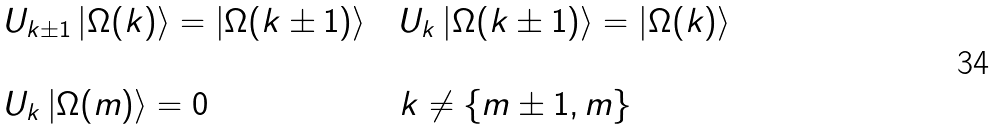Convert formula to latex. <formula><loc_0><loc_0><loc_500><loc_500>\begin{array} { l l l } U _ { k \pm 1 } \left | \Omega ( k ) \right \rangle = \left | \Omega ( k \pm 1 ) \right \rangle & & U _ { k } \left | \Omega ( k \pm 1 ) \right \rangle = \left | \Omega ( k ) \right \rangle \\ & & \\ U _ { k } \left | \Omega ( m ) \right \rangle = 0 & & k \neq \{ m \pm 1 , m \} \end{array}</formula> 